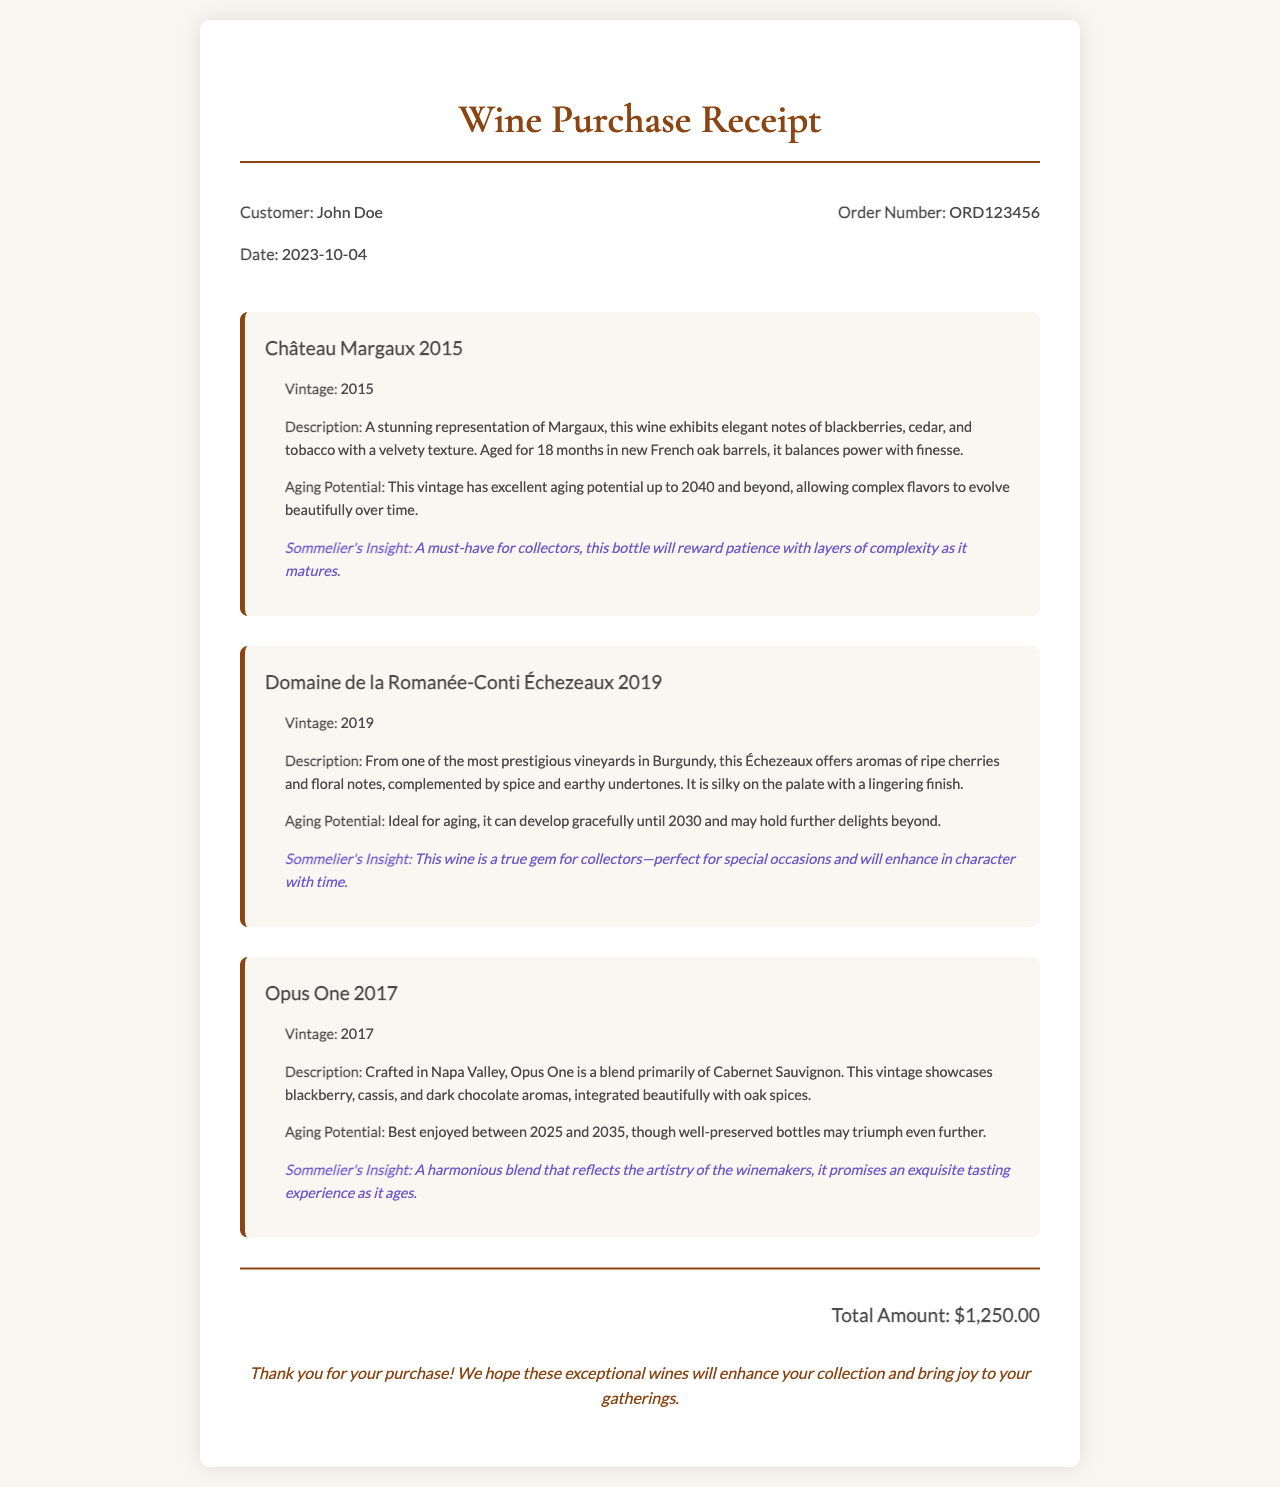What is the customer's name? The receipt states the customer's name at the top of the document.
Answer: John Doe What is the order number? The order number is indicated in the receipt header section.
Answer: ORD123456 What is the total amount? The total amount is displayed at the bottom of the receipt.
Answer: $1,250.00 In what year is Château Margaux vintage? The vintage year for Château Margaux is mentioned in its details section.
Answer: 2015 What scent notes are described for Domaine de la Romanée-Conti Échezeaux? The description provides specific scent notes for the wine.
Answer: Ripe cherries and floral notes What is the aging potential of Opus One? The aging potential for Opus One is clearly stated in its details.
Answer: 2025 to 2035 Which wine is recommended to collect for its layers of complexity? The sommelier's insight gives a specific recommendation regarding aging.
Answer: Château Margaux 2015 When is the ideal aging for Domaine de la Romanée-Conti Échezeaux? The ideal aging timeframe is explicitly mentioned in the details of that wine.
Answer: Until 2030 What type of wine is mainly used in Opus One blend? The document specifies the main type of wine used in the blend.
Answer: Cabernet Sauvignon 